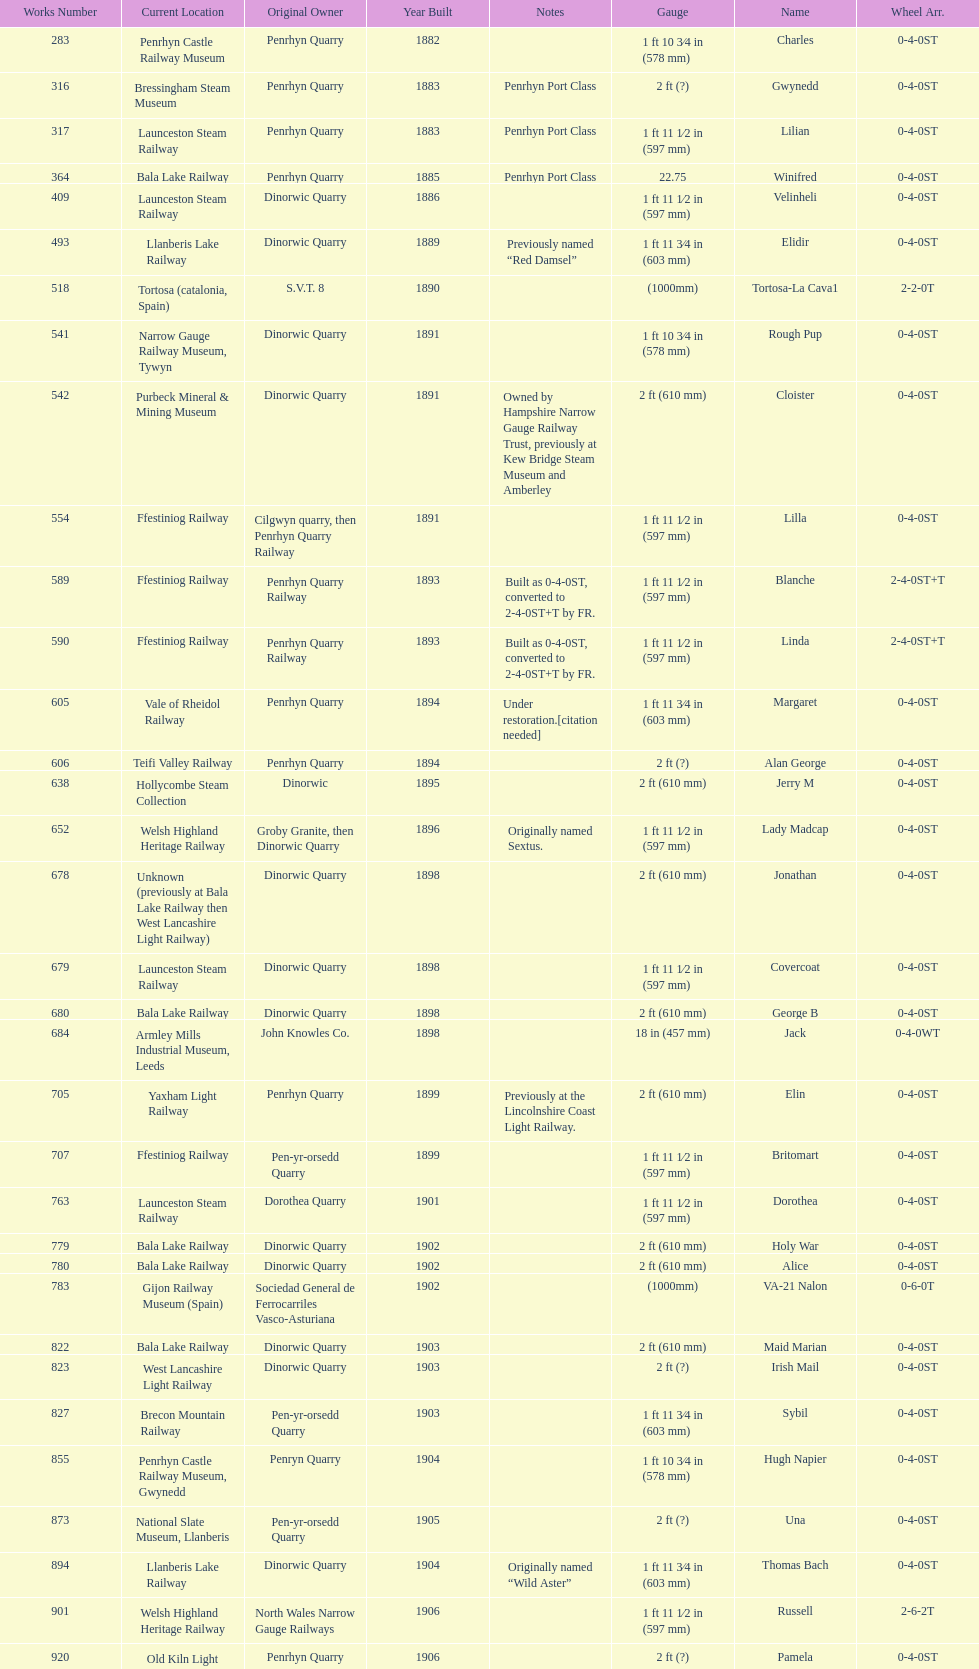In which year were the most steam locomotives built? 1898. Can you give me this table as a dict? {'header': ['Works Number', 'Current Location', 'Original Owner', 'Year Built', 'Notes', 'Gauge', 'Name', 'Wheel Arr.'], 'rows': [['283', 'Penrhyn Castle Railway Museum', 'Penrhyn Quarry', '1882', '', '1\xa0ft 10\xa03⁄4\xa0in (578\xa0mm)', 'Charles', '0-4-0ST'], ['316', 'Bressingham Steam Museum', 'Penrhyn Quarry', '1883', 'Penrhyn Port Class', '2\xa0ft (?)', 'Gwynedd', '0-4-0ST'], ['317', 'Launceston Steam Railway', 'Penrhyn Quarry', '1883', 'Penrhyn Port Class', '1\xa0ft 11\xa01⁄2\xa0in (597\xa0mm)', 'Lilian', '0-4-0ST'], ['364', 'Bala Lake Railway', 'Penrhyn Quarry', '1885', 'Penrhyn Port Class', '22.75', 'Winifred', '0-4-0ST'], ['409', 'Launceston Steam Railway', 'Dinorwic Quarry', '1886', '', '1\xa0ft 11\xa01⁄2\xa0in (597\xa0mm)', 'Velinheli', '0-4-0ST'], ['493', 'Llanberis Lake Railway', 'Dinorwic Quarry', '1889', 'Previously named “Red Damsel”', '1\xa0ft 11\xa03⁄4\xa0in (603\xa0mm)', 'Elidir', '0-4-0ST'], ['518', 'Tortosa (catalonia, Spain)', 'S.V.T. 8', '1890', '', '(1000mm)', 'Tortosa-La Cava1', '2-2-0T'], ['541', 'Narrow Gauge Railway Museum, Tywyn', 'Dinorwic Quarry', '1891', '', '1\xa0ft 10\xa03⁄4\xa0in (578\xa0mm)', 'Rough Pup', '0-4-0ST'], ['542', 'Purbeck Mineral & Mining Museum', 'Dinorwic Quarry', '1891', 'Owned by Hampshire Narrow Gauge Railway Trust, previously at Kew Bridge Steam Museum and Amberley', '2\xa0ft (610\xa0mm)', 'Cloister', '0-4-0ST'], ['554', 'Ffestiniog Railway', 'Cilgwyn quarry, then Penrhyn Quarry Railway', '1891', '', '1\xa0ft 11\xa01⁄2\xa0in (597\xa0mm)', 'Lilla', '0-4-0ST'], ['589', 'Ffestiniog Railway', 'Penrhyn Quarry Railway', '1893', 'Built as 0-4-0ST, converted to 2-4-0ST+T by FR.', '1\xa0ft 11\xa01⁄2\xa0in (597\xa0mm)', 'Blanche', '2-4-0ST+T'], ['590', 'Ffestiniog Railway', 'Penrhyn Quarry Railway', '1893', 'Built as 0-4-0ST, converted to 2-4-0ST+T by FR.', '1\xa0ft 11\xa01⁄2\xa0in (597\xa0mm)', 'Linda', '2-4-0ST+T'], ['605', 'Vale of Rheidol Railway', 'Penrhyn Quarry', '1894', 'Under restoration.[citation needed]', '1\xa0ft 11\xa03⁄4\xa0in (603\xa0mm)', 'Margaret', '0-4-0ST'], ['606', 'Teifi Valley Railway', 'Penrhyn Quarry', '1894', '', '2\xa0ft (?)', 'Alan George', '0-4-0ST'], ['638', 'Hollycombe Steam Collection', 'Dinorwic', '1895', '', '2\xa0ft (610\xa0mm)', 'Jerry M', '0-4-0ST'], ['652', 'Welsh Highland Heritage Railway', 'Groby Granite, then Dinorwic Quarry', '1896', 'Originally named Sextus.', '1\xa0ft 11\xa01⁄2\xa0in (597\xa0mm)', 'Lady Madcap', '0-4-0ST'], ['678', 'Unknown (previously at Bala Lake Railway then West Lancashire Light Railway)', 'Dinorwic Quarry', '1898', '', '2\xa0ft (610\xa0mm)', 'Jonathan', '0-4-0ST'], ['679', 'Launceston Steam Railway', 'Dinorwic Quarry', '1898', '', '1\xa0ft 11\xa01⁄2\xa0in (597\xa0mm)', 'Covercoat', '0-4-0ST'], ['680', 'Bala Lake Railway', 'Dinorwic Quarry', '1898', '', '2\xa0ft (610\xa0mm)', 'George B', '0-4-0ST'], ['684', 'Armley Mills Industrial Museum, Leeds', 'John Knowles Co.', '1898', '', '18\xa0in (457\xa0mm)', 'Jack', '0-4-0WT'], ['705', 'Yaxham Light Railway', 'Penrhyn Quarry', '1899', 'Previously at the Lincolnshire Coast Light Railway.', '2\xa0ft (610\xa0mm)', 'Elin', '0-4-0ST'], ['707', 'Ffestiniog Railway', 'Pen-yr-orsedd Quarry', '1899', '', '1\xa0ft 11\xa01⁄2\xa0in (597\xa0mm)', 'Britomart', '0-4-0ST'], ['763', 'Launceston Steam Railway', 'Dorothea Quarry', '1901', '', '1\xa0ft 11\xa01⁄2\xa0in (597\xa0mm)', 'Dorothea', '0-4-0ST'], ['779', 'Bala Lake Railway', 'Dinorwic Quarry', '1902', '', '2\xa0ft (610\xa0mm)', 'Holy War', '0-4-0ST'], ['780', 'Bala Lake Railway', 'Dinorwic Quarry', '1902', '', '2\xa0ft (610\xa0mm)', 'Alice', '0-4-0ST'], ['783', 'Gijon Railway Museum (Spain)', 'Sociedad General de Ferrocarriles Vasco-Asturiana', '1902', '', '(1000mm)', 'VA-21 Nalon', '0-6-0T'], ['822', 'Bala Lake Railway', 'Dinorwic Quarry', '1903', '', '2\xa0ft (610\xa0mm)', 'Maid Marian', '0-4-0ST'], ['823', 'West Lancashire Light Railway', 'Dinorwic Quarry', '1903', '', '2\xa0ft (?)', 'Irish Mail', '0-4-0ST'], ['827', 'Brecon Mountain Railway', 'Pen-yr-orsedd Quarry', '1903', '', '1\xa0ft 11\xa03⁄4\xa0in (603\xa0mm)', 'Sybil', '0-4-0ST'], ['855', 'Penrhyn Castle Railway Museum, Gwynedd', 'Penryn Quarry', '1904', '', '1\xa0ft 10\xa03⁄4\xa0in (578\xa0mm)', 'Hugh Napier', '0-4-0ST'], ['873', 'National Slate Museum, Llanberis', 'Pen-yr-orsedd Quarry', '1905', '', '2\xa0ft (?)', 'Una', '0-4-0ST'], ['894', 'Llanberis Lake Railway', 'Dinorwic Quarry', '1904', 'Originally named “Wild Aster”', '1\xa0ft 11\xa03⁄4\xa0in (603\xa0mm)', 'Thomas Bach', '0-4-0ST'], ['901', 'Welsh Highland Heritage Railway', 'North Wales Narrow Gauge Railways', '1906', '', '1\xa0ft 11\xa01⁄2\xa0in (597\xa0mm)', 'Russell', '2-6-2T'], ['920', 'Old Kiln Light Railway', 'Penrhyn Quarry', '1906', '', '2\xa0ft (?)', 'Pamela', '0-4-0ST'], ['994', 'Bressingham Steam Museum', 'Penrhyn Quarry', '1909', 'previously George Sholto', '2\xa0ft (?)', 'Bill Harvey', '0-4-0ST'], ['1312', 'Pampas Safari, Gravataí, RS, Brazil', 'British War Department\\nEFOP #203', '1918', '[citation needed]', '1\xa0ft\xa011\xa01⁄2\xa0in (597\xa0mm)', '---', '4-6-0T'], ['1313', 'Usina Laginha, União dos Palmares, AL, Brazil', 'British War Department\\nUsina Leão Utinga #1\\nUsina Laginha #1', '1918\\nor\\n1921?', '[citation needed]', '3\xa0ft\xa03\xa03⁄8\xa0in (1,000\xa0mm)', '---', '0-6-2T'], ['1404', 'Richard Farmer current owner, Northridge, California, USA', 'John Knowles Co.', '1920', '', '18\xa0in (457\xa0mm)', 'Gwen', '0-4-0WT'], ['1429', 'Bredgar and Wormshill Light Railway', 'Dinorwic', '1922', '', '2\xa0ft (610\xa0mm)', 'Lady Joan', '0-4-0ST'], ['1430', 'Llanberis Lake Railway', 'Dinorwic Quarry', '1922', '', '1\xa0ft 11\xa03⁄4\xa0in (603\xa0mm)', 'Dolbadarn', '0-4-0ST'], ['1859', 'South Tynedale Railway', 'Umtwalumi Valley Estate, Natal', '1937', '', '2\xa0ft (?)', '16 Carlisle', '0-4-2T'], ['2075', 'North Gloucestershire Railway', 'Chaka’s Kraal Sugar Estates, Natal', '1940', '', '2\xa0ft (?)', 'Chaka’s Kraal No. 6', '0-4-2T'], ['3815', 'Welshpool and Llanfair Light Railway', 'Sierra Leone Government Railway', '1954', '', '2\xa0ft 6\xa0in (762\xa0mm)', '14', '2-6-2T'], ['3902', 'Statfold Barn Railway', 'Trangkil Sugar Mill, Indonesia', '1971', 'Converted from 750\xa0mm (2\xa0ft\xa05\xa01⁄2\xa0in) gauge. Last steam locomotive to be built by Hunslet, and the last industrial steam locomotive built in Britain.', '2\xa0ft (610\xa0mm)', 'Trangkil No.4', '0-4-2ST']]} 